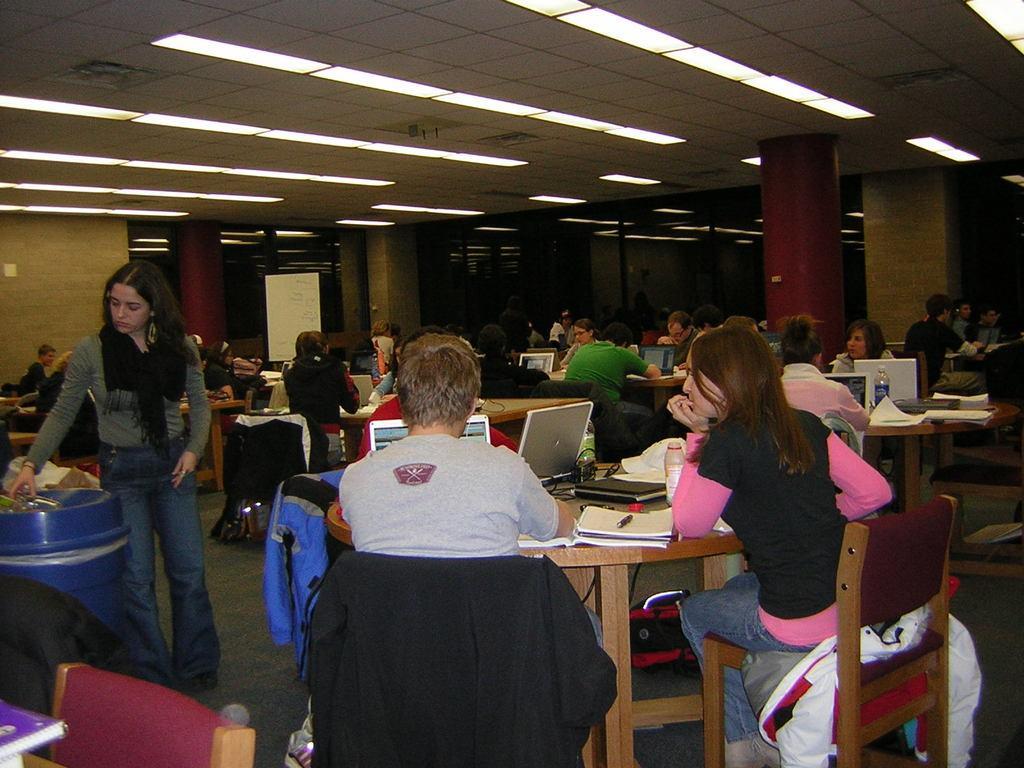Describe this image in one or two sentences. Here we can see groups of people sitting on chairs with a table having laptops and books present in front of them and then at the left side we can see a woman throwing trash and at the top we can see lights 